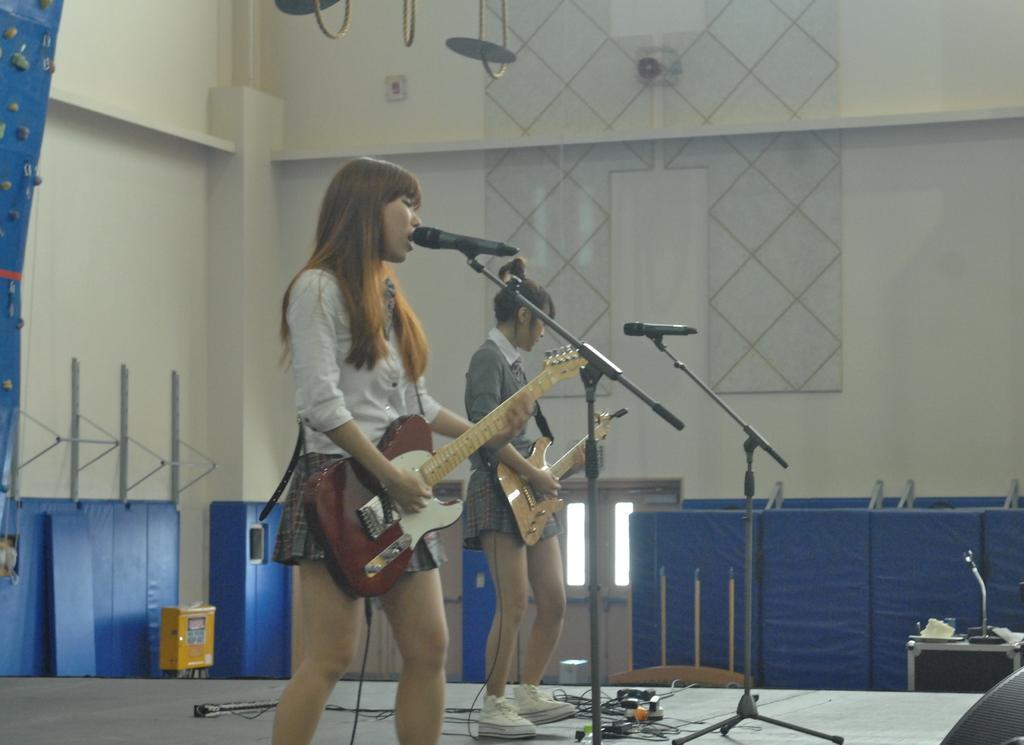Please provide a concise description of this image. 2 people are standing on the stage and playing guitar. the person at the left is singing. there are 2 microphones present in front of them. behind them there is white wall. on the floor there are blue stands. at the center back there is a door. the person at left is wearing a white shirt and a short skirt. 